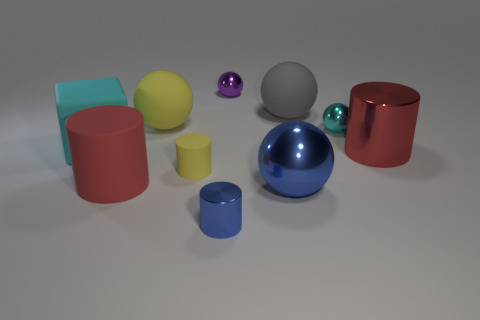Is the number of rubber blocks that are on the left side of the big matte block less than the number of brown spheres?
Provide a succinct answer. No. What is the shape of the tiny yellow thing that is made of the same material as the large cyan thing?
Your answer should be compact. Cylinder. How many metallic cylinders have the same color as the large metal ball?
Your answer should be very brief. 1. How many objects are either tiny purple metal objects or big purple cubes?
Your answer should be very brief. 1. What is the material of the thing that is left of the large red cylinder on the left side of the cyan metallic object?
Your answer should be compact. Rubber. Is there a large red cylinder that has the same material as the tiny blue cylinder?
Keep it short and to the point. Yes. What shape is the purple shiny thing that is behind the yellow thing that is behind the large cylinder that is behind the tiny rubber cylinder?
Provide a short and direct response. Sphere. What is the small purple sphere made of?
Provide a short and direct response. Metal. There is a big cylinder that is the same material as the small blue cylinder; what is its color?
Ensure brevity in your answer.  Red. There is a big sphere right of the blue metal ball; is there a cube that is behind it?
Keep it short and to the point. No. 